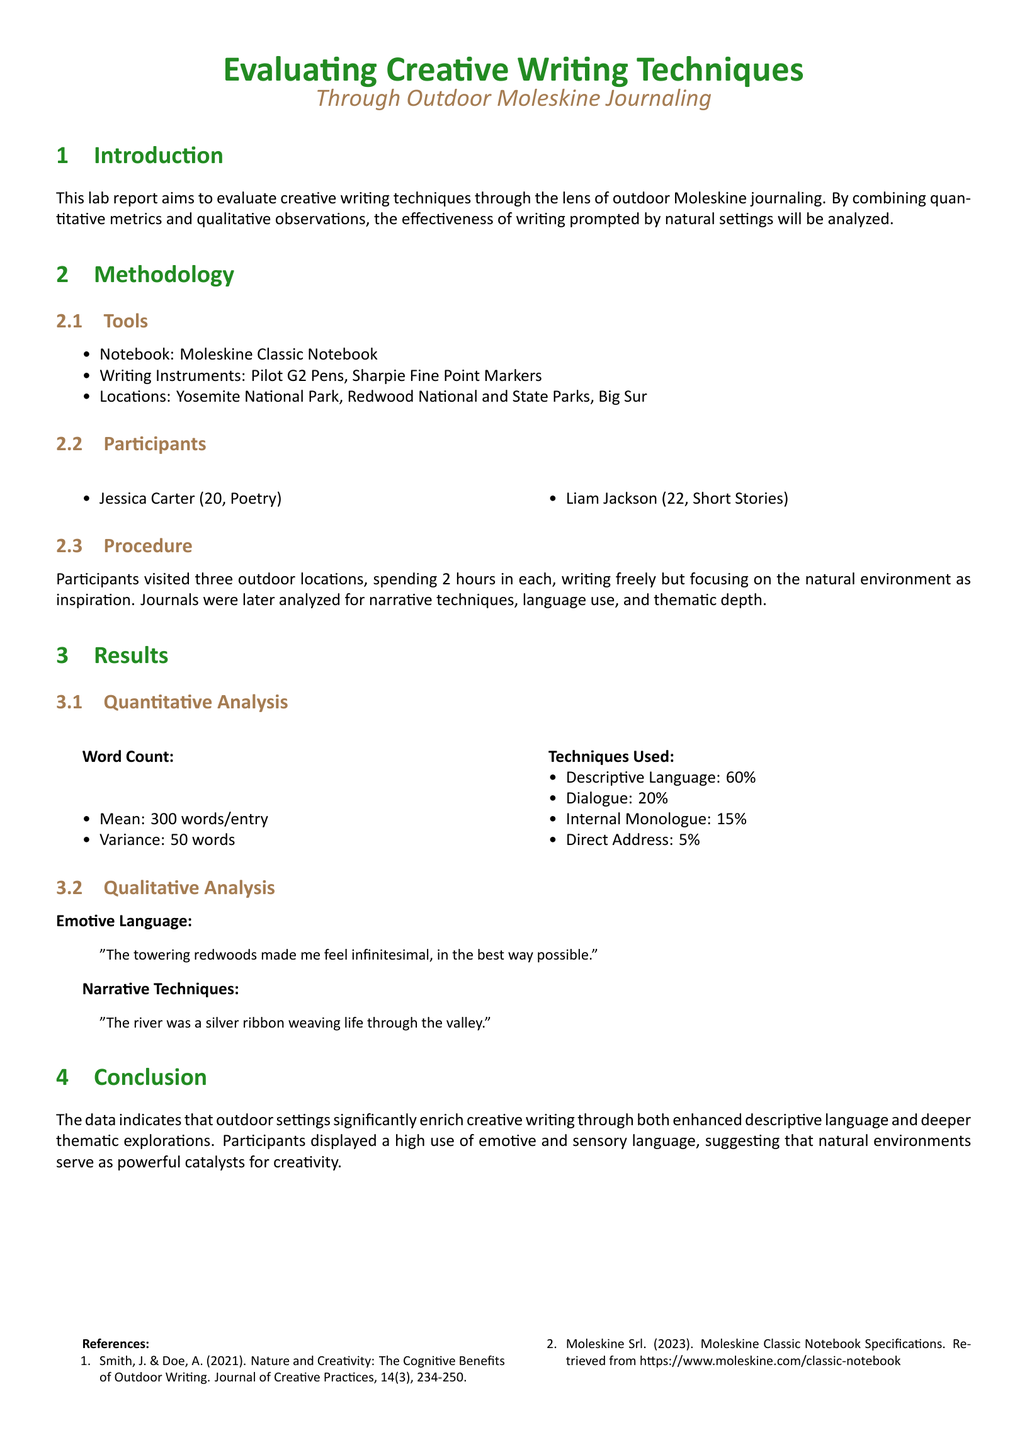What are the names of the participants? The names of the participants are listed in the Participants section, which shows Jessica Carter and Liam Jackson.
Answer: Jessica Carter, Liam Jackson What location did the participants visit first? The locations the participants visited are outlined in the Methodology section, and Yosemite National Park is mentioned first.
Answer: Yosemite National Park What is the mean word count per entry? The mean word count is provided in the Quantitative Analysis subsection, indicating the average words written by participants in each journal entry.
Answer: 300 words What percentage of the writing used descriptive language? The percentage for descriptive language usage is included under the Techniques Used in the Results section, specifically indicating a high usage rate.
Answer: 60% What narrative technique is highlighted in the qualitative analysis? A quote in the Qualitative Analysis section emphasizes a specific narrative technique, showcasing the effectiveness of metaphor.
Answer: The river was a silver ribbon weaving life through the valley What is the variance in word count? The variance in word count supplied in the Quantitative Analysis gives insight into the variability of the entries produced during journaling.
Answer: 50 words What outdoor settings were emphasized in the conclusion? The Conclusion section summarizes the findings, focusing on how outdoor settings enhance writing creativity and depth.
Answer: Outdoor settings What tools were used for journaling? The Methodology section lists the tools utilized for the journaling process, which includes specific writing instruments.
Answer: Moleskine Classic Notebook, Pilot G2 Pens, Sharpie Fine Point Markers What year was the study by Smith and Doe published? The citation under References provides the publication year of the relevant study used in the lab report.
Answer: 2021 